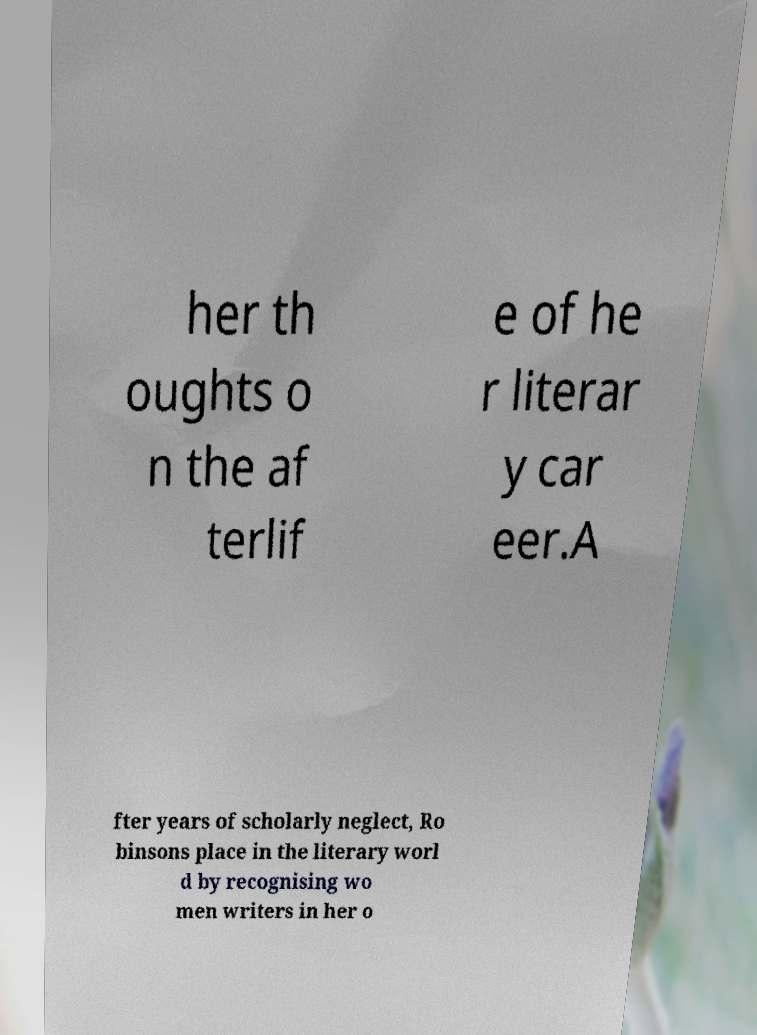Please identify and transcribe the text found in this image. her th oughts o n the af terlif e of he r literar y car eer.A fter years of scholarly neglect, Ro binsons place in the literary worl d by recognising wo men writers in her o 